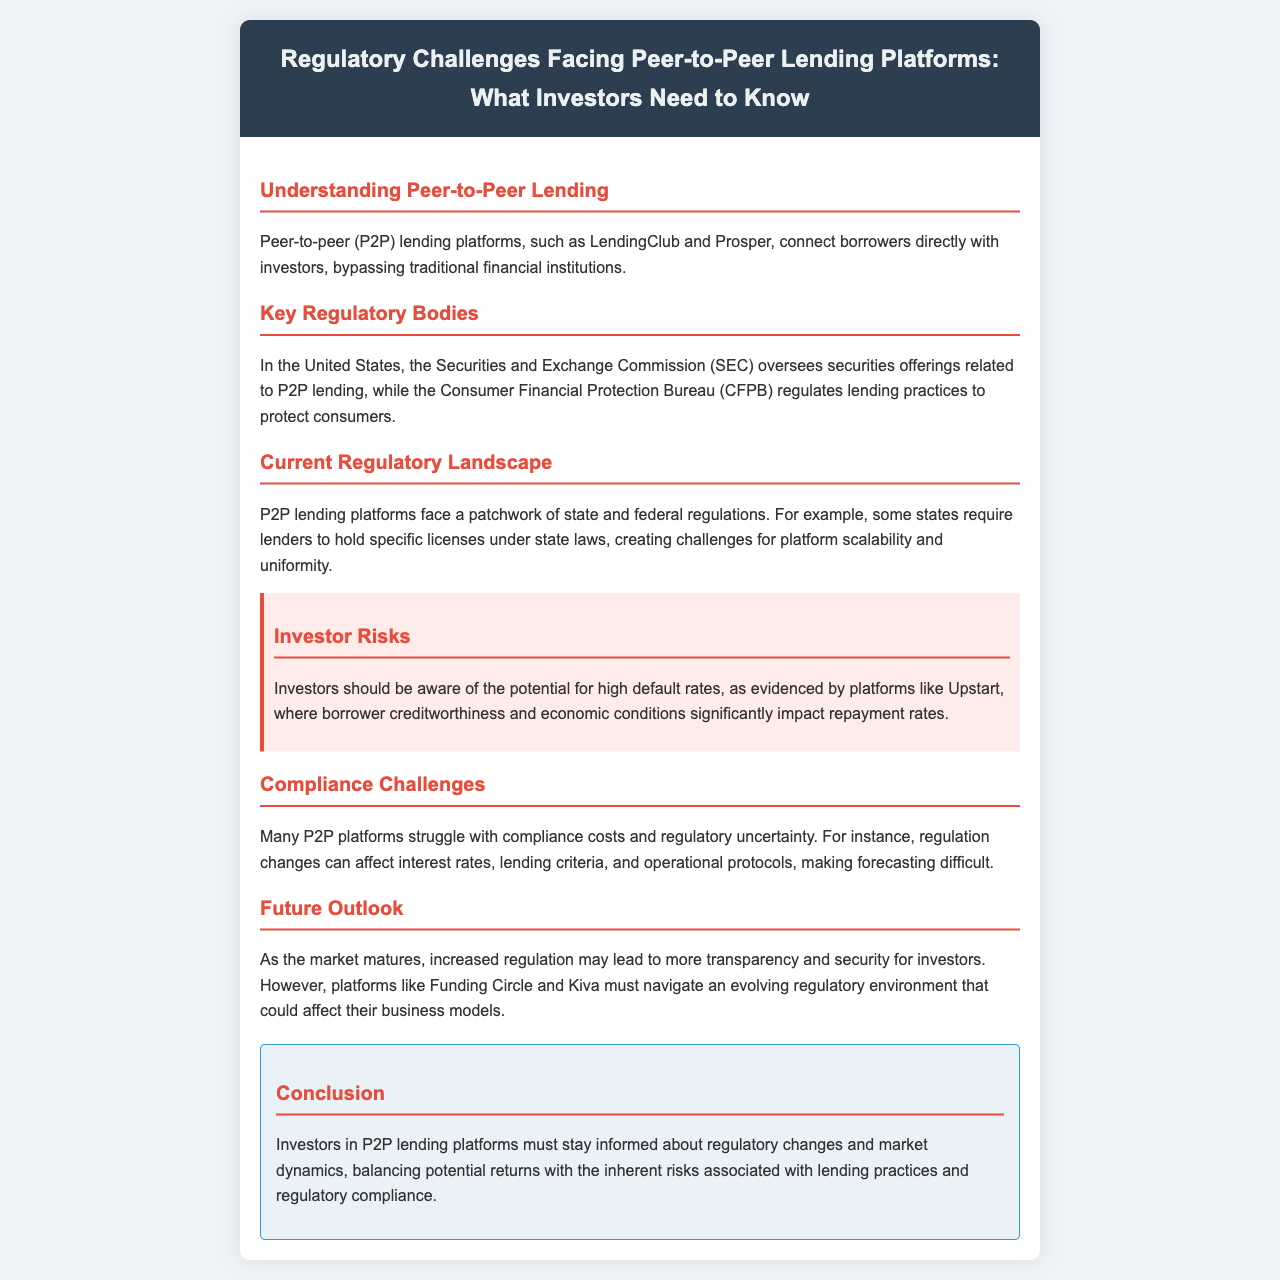What do P2P lending platforms do? P2P lending platforms connect borrowers directly with investors, bypassing traditional financial institutions.
Answer: connect borrowers directly with investors Which regulatory body oversees securities offerings related to P2P lending in the U.S.? The document states that the Securities and Exchange Commission (SEC) oversees securities offerings related to P2P lending.
Answer: Securities and Exchange Commission (SEC) What is a potential risk mentioned for investors in P2P lending? The brochure warns about the potential for high default rates affecting repayment rates on P2P lending platforms.
Answer: high default rates What compliance challenge do many P2P platforms face? The document mentions that many P2P platforms struggle with compliance costs and regulatory uncertainty.
Answer: compliance costs and regulatory uncertainty What does the future outlook suggest about regulatory impacts on transparency? The document states that increased regulation may lead to more transparency and security for investors.
Answer: more transparency and security What type of document is this? This document serves as a brochure providing information about regulatory challenges in P2P lending.
Answer: brochure Which two platforms are mentioned as examples in the future outlook section? The document lists Funding Circle and Kiva as examples in the future outlook section.
Answer: Funding Circle and Kiva What agency regulates lending practices to protect consumers? The Consumer Financial Protection Bureau (CFPB) is mentioned as the agency that regulates lending practices.
Answer: Consumer Financial Protection Bureau (CFPB) 